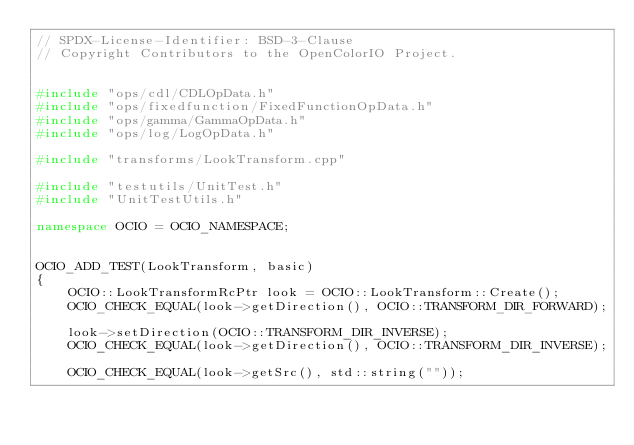Convert code to text. <code><loc_0><loc_0><loc_500><loc_500><_C++_>// SPDX-License-Identifier: BSD-3-Clause
// Copyright Contributors to the OpenColorIO Project.


#include "ops/cdl/CDLOpData.h"
#include "ops/fixedfunction/FixedFunctionOpData.h"
#include "ops/gamma/GammaOpData.h"
#include "ops/log/LogOpData.h"

#include "transforms/LookTransform.cpp"

#include "testutils/UnitTest.h"
#include "UnitTestUtils.h"

namespace OCIO = OCIO_NAMESPACE;


OCIO_ADD_TEST(LookTransform, basic)
{
    OCIO::LookTransformRcPtr look = OCIO::LookTransform::Create();
    OCIO_CHECK_EQUAL(look->getDirection(), OCIO::TRANSFORM_DIR_FORWARD);

    look->setDirection(OCIO::TRANSFORM_DIR_INVERSE);
    OCIO_CHECK_EQUAL(look->getDirection(), OCIO::TRANSFORM_DIR_INVERSE);

    OCIO_CHECK_EQUAL(look->getSrc(), std::string(""));</code> 